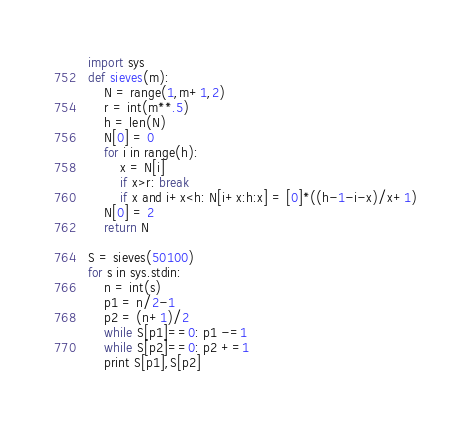Convert code to text. <code><loc_0><loc_0><loc_500><loc_500><_Python_>import sys 
def sieves(m):
    N = range(1,m+1,2)
    r = int(m**.5)
    h = len(N)
    N[0] = 0
    for i in range(h):
        x = N[i]
        if x>r: break
        if x and i+x<h: N[i+x:h:x] = [0]*((h-1-i-x)/x+1)
    N[0] = 2
    return N

S = sieves(50100)
for s in sys.stdin:
    n = int(s)
    p1 = n/2-1
    p2 = (n+1)/2
    while S[p1]==0: p1 -=1
    while S[p2]==0: p2 +=1
    print S[p1],S[p2]</code> 